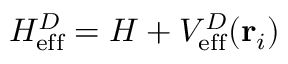Convert formula to latex. <formula><loc_0><loc_0><loc_500><loc_500>H _ { e f f } ^ { D } = H + V _ { e f f } ^ { D } ( { r } _ { i } )</formula> 